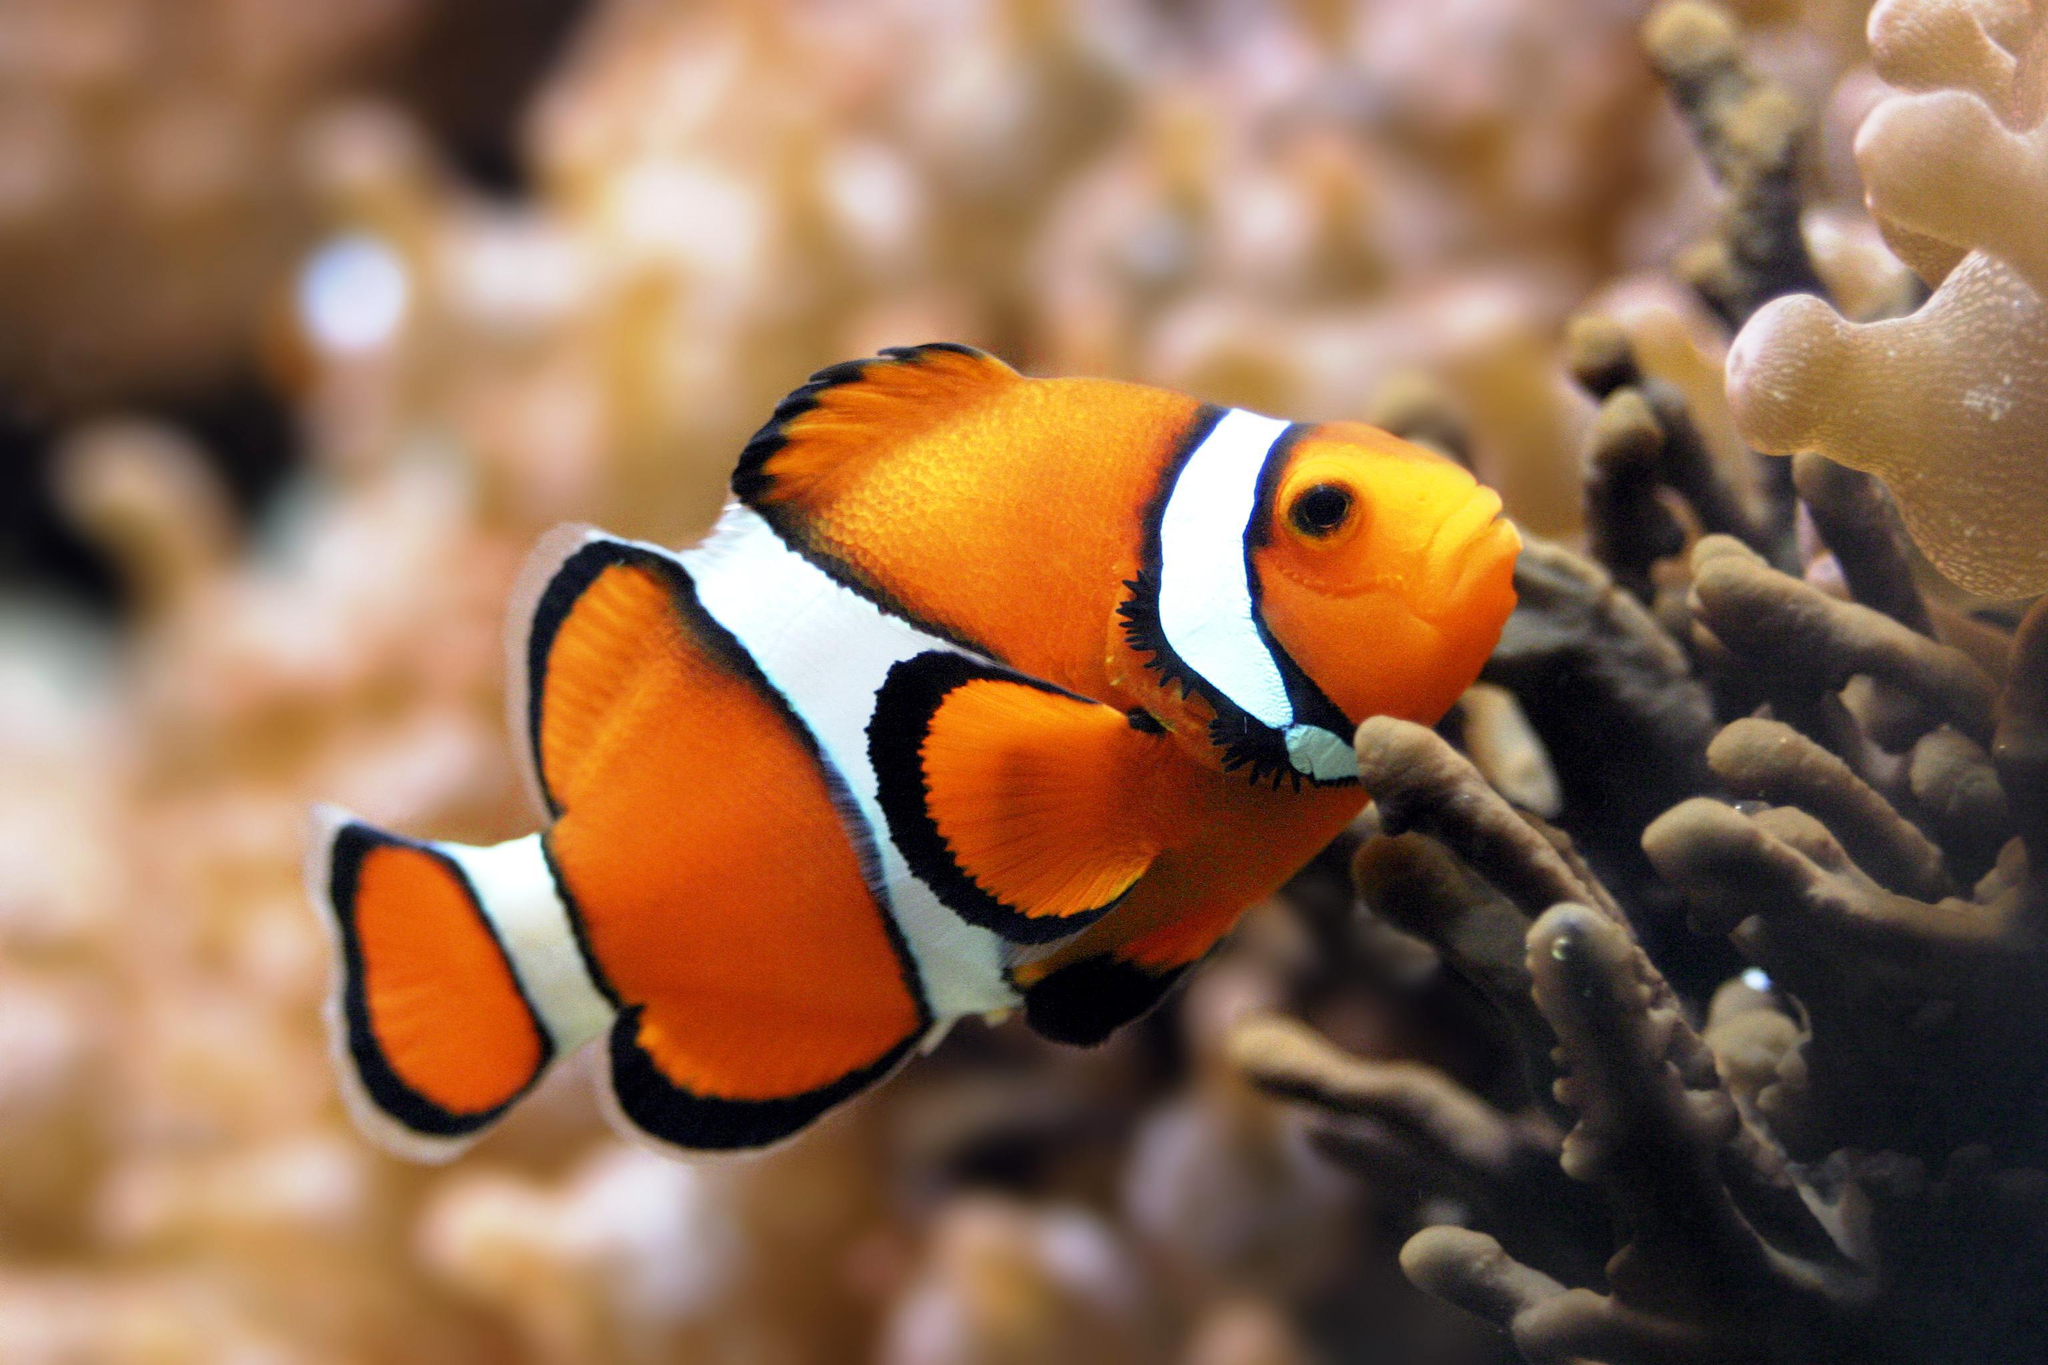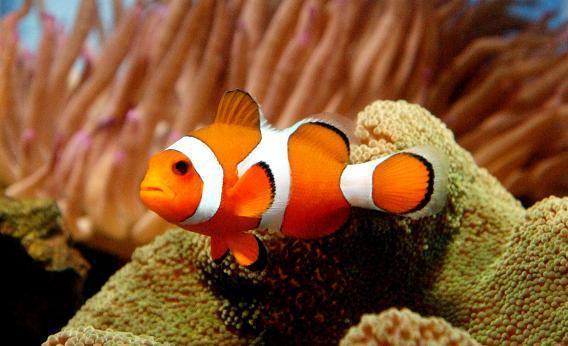The first image is the image on the left, the second image is the image on the right. For the images shown, is this caption "Three clown fish are shown, in total." true? Answer yes or no. No. 